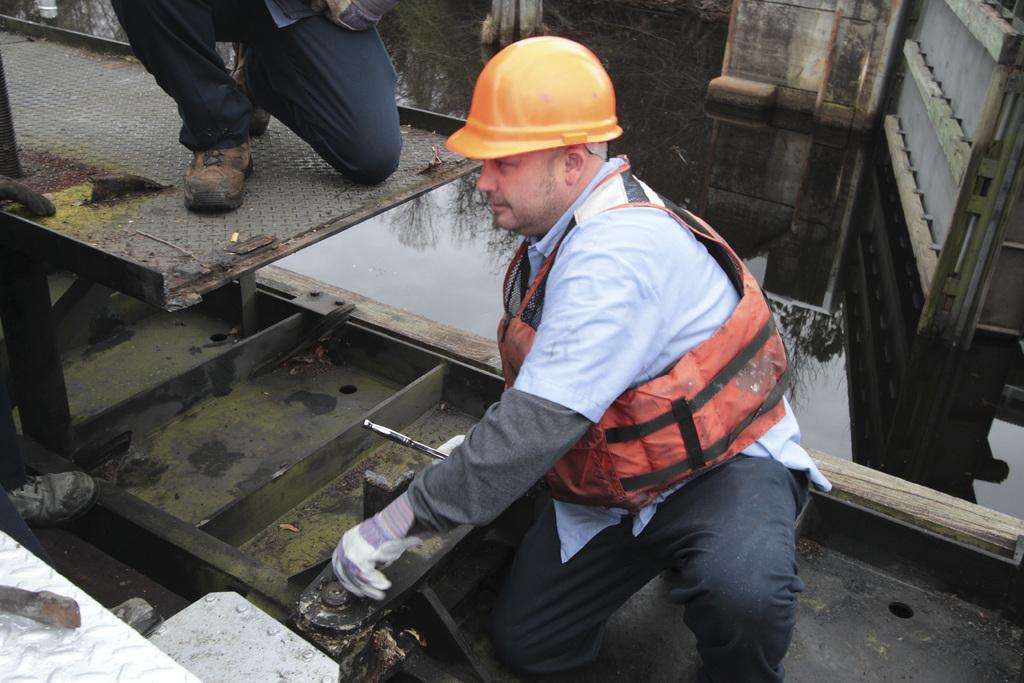What is the person in the image wearing on their head? The person in the image is wearing a helmet. What type of clothing is the person wearing to protect themselves? The person is wearing a safety jacket. What type of hand covering is the person wearing? The person is wearing gloves. Can you describe the second person in the image? There is another person behind the first person. What can be seen in the background of the image? There is water and trees visible in the background. What type of list can be seen in the image? There is no list present in the image. How many cloud formations can be seen in the image? There is no mention of clouds in the image; it only mentions water and trees in the background. Can you describe the ladybug on the person's shoulder in the image? There is no ladybug present in the image. 